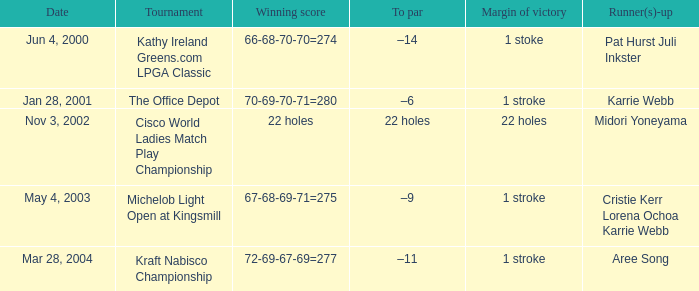On what date were pat hurst and juli inkster the runner-ups? Jun 4, 2000. 